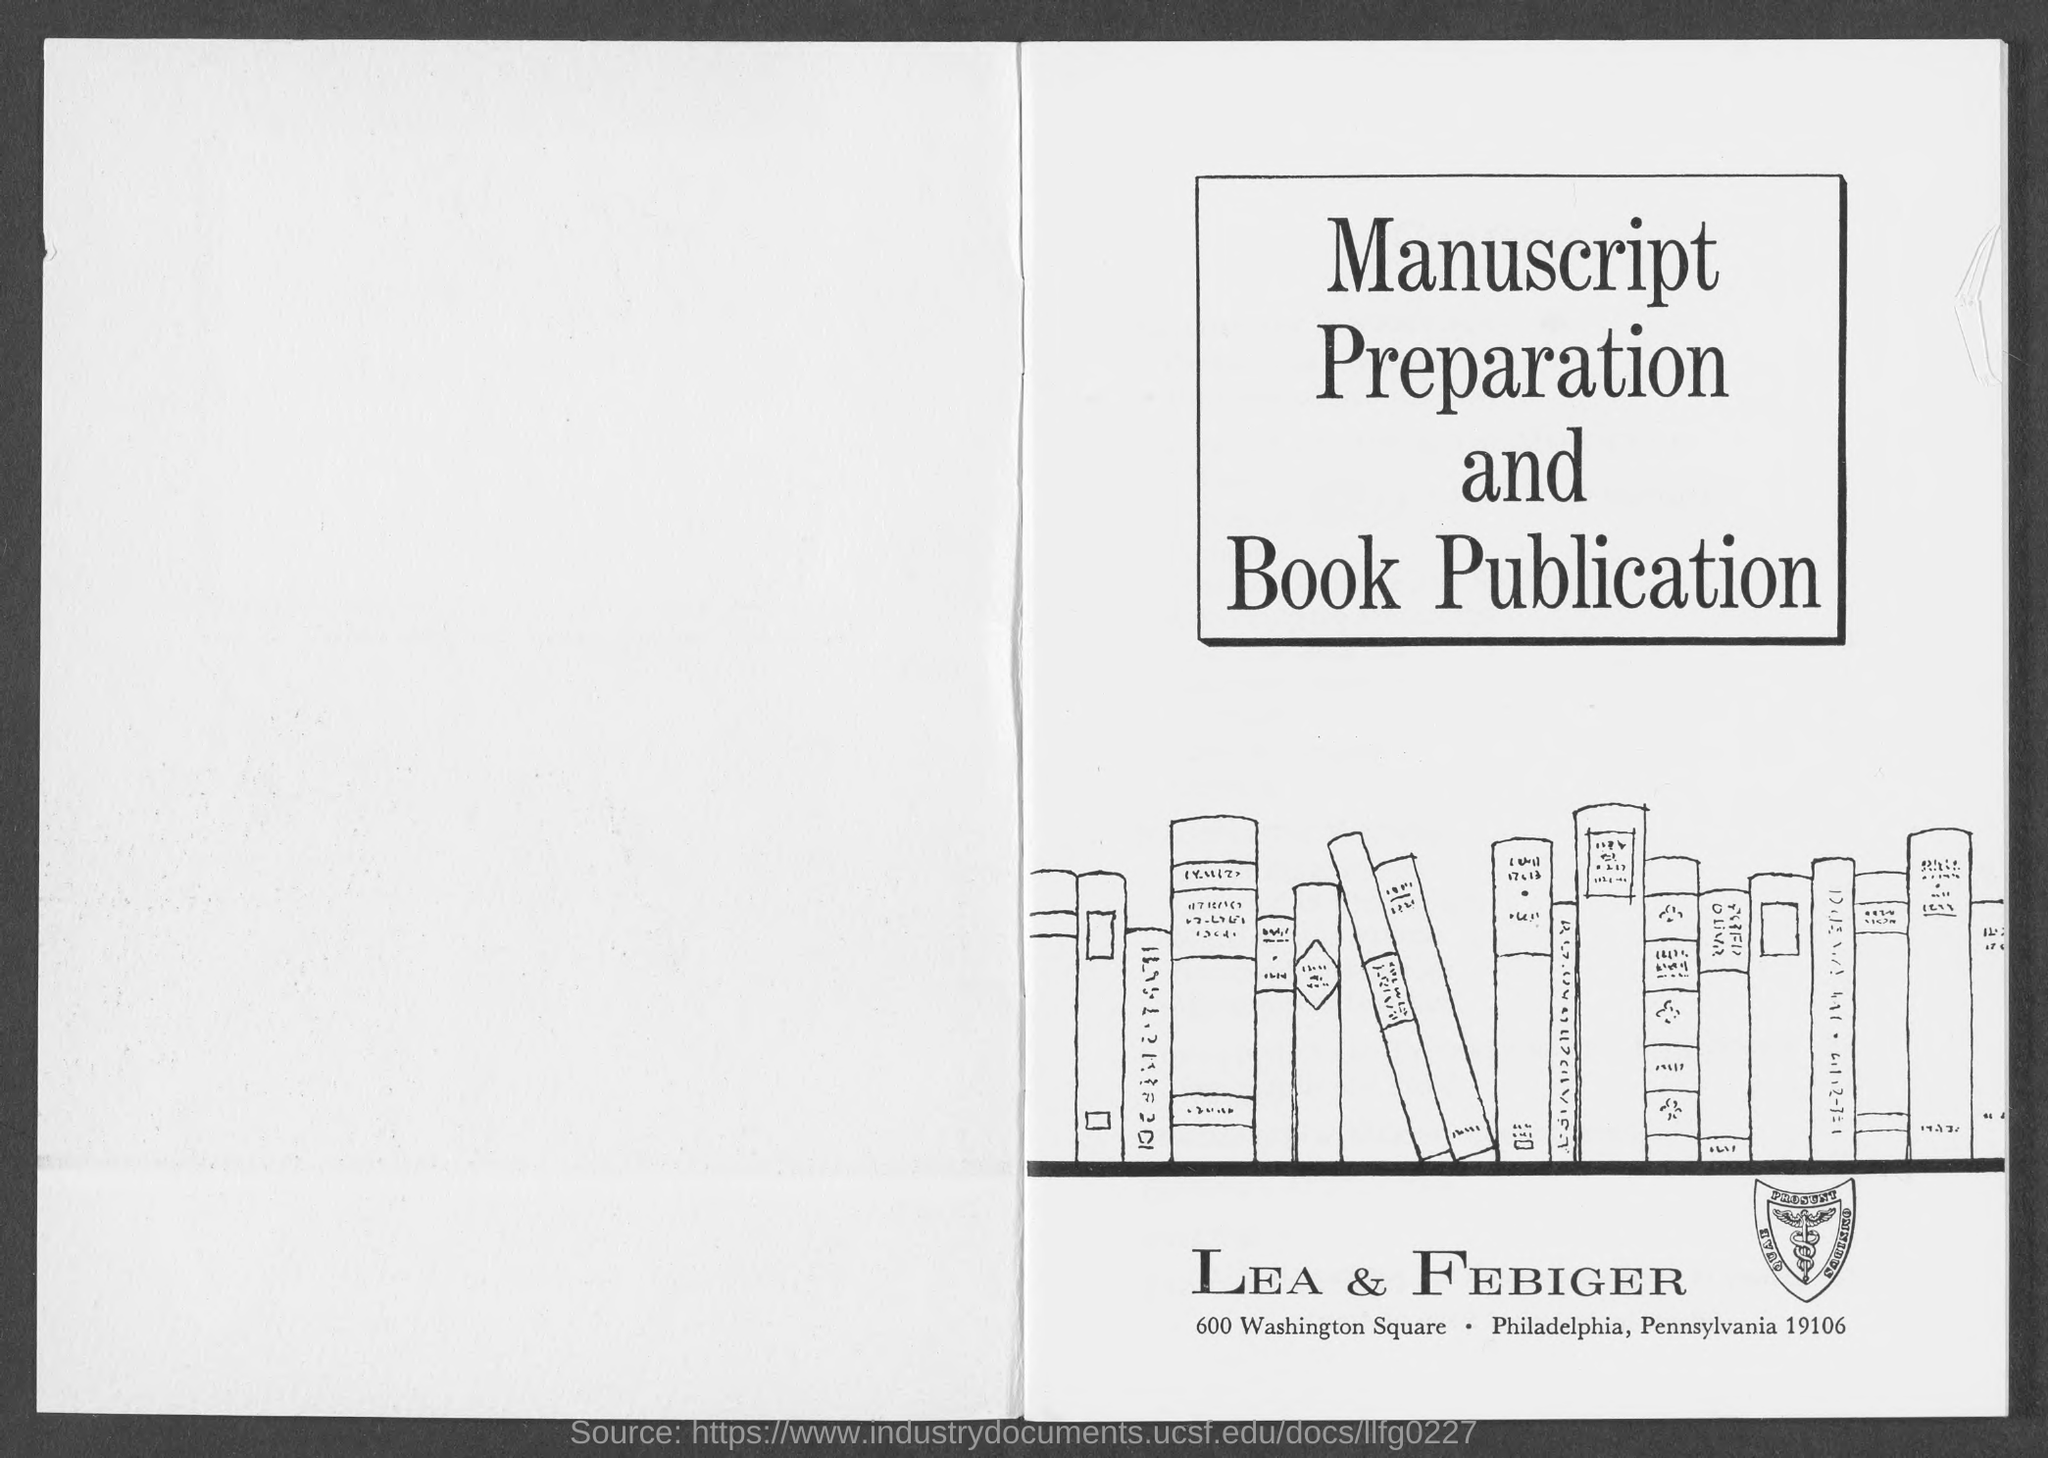Highlight a few significant elements in this photo. Lea & Febiger is located in the city of Philadelphia. 